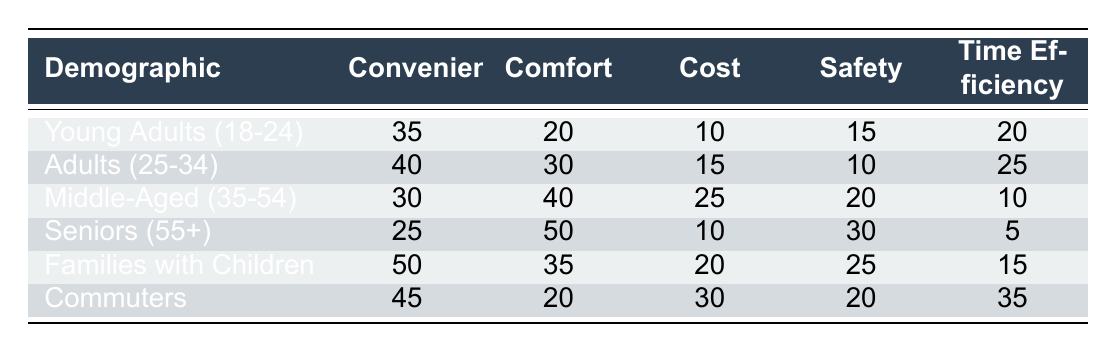What is the highest reason for choosing taxi among Young Adults (18-24)? The table shows that convenience is the highest reason for choosing taxi among Young Adults (18-24) with a value of 35.
Answer: 35 Which demographic has the lowest score for Safety? By examining the Safety column, we see that Seniors (55+) has the lowest value of 30, indicating they perceive the least concern regarding Safety compared to others.
Answer: 30 What are the total scores for Comfort across all demographics? We sum the values in the Comfort column: 20 (Young Adults) + 30 (Adults) + 40 (Middle-Aged) + 50 (Seniors) + 35 (Families) + 20 (Commuters) = 195.
Answer: 195 Is it true that Families with Children give a higher preference for Comfort than Safety? Looking at the values, Families with Children have 35 for Comfort and 25 for Safety. Since 35 > 25, the statement is true.
Answer: Yes Which demographic values Time Efficiency the most? Commuters provide the highest value for Time Efficiency, which is 35, compared to other demographics.
Answer: 35 What is the average value for Convenience across all demographics? The average is calculated by summing the Convenience values: 35 + 40 + 30 + 25 + 50 + 45 = 225. There are 6 demographics, so the average is 225/6 = 37.5.
Answer: 37.5 How does the Cost preference compare between Adults (25-34) and Families with Children? Adults (25-34) have a Cost preference of 15, while Families with Children show a preference of 20. Comparing these, Families with Children have a higher preference.
Answer: Yes What is the difference in Convenience between Commuters and Seniors? Convenience for Commuters is 45, and for Seniors, it is 25. The difference is 45 - 25 = 20.
Answer: 20 Which demographic uses the least Time Efficiency when choosing taxis? The table shows that Seniors (55+) place the least value on Time Efficiency, which is 5, compared to all other demographics.
Answer: 5 